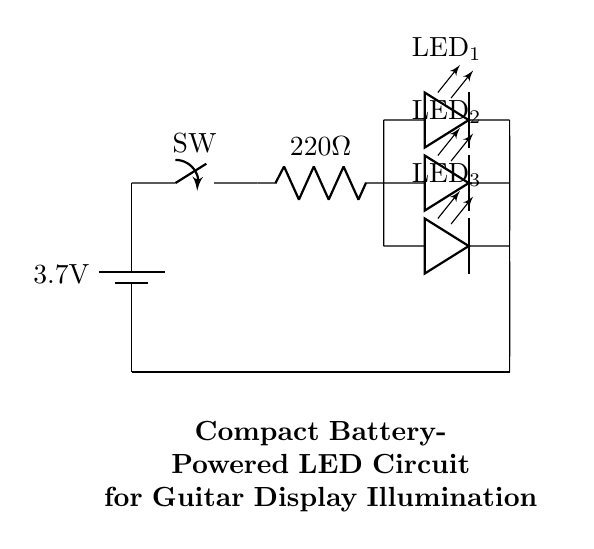What is the voltage of the battery? The circuit diagram shows a battery marked with a voltage of 3.7V. This is a direct indication of the voltage supply in the circuit.
Answer: 3.7 volts How many LEDs are there in this circuit? The circuit shows three LEDs connected in parallel. Counting the labeled LEDs in the diagram reveals that there are exactly three LEDs.
Answer: Three What is the resistance value of the resistor? In the diagram, there is a resistor labeled with a value of 220 ohms. This provides the resistance level for current limiting in the circuit.
Answer: 220 ohms What kind of switch is used in this circuit? The diagram indicates a switch labeled as "SW", which signifies a generic switch type commonly used for controlling circuits. While its specific type is not detailed, it is generally understood to be a toggle or slide switch.
Answer: Toggle switch Are the LEDs connected in series or parallel? Upon examining the connections in the diagram, the LED components branch off from a common point, indicating that they are in parallel. This means each LED receives the same voltage across them.
Answer: Parallel What is the purpose of the resistor in this circuit? The resistor is used to limit the current flowing through the LEDs. By converting the voltage from the battery and controlling the flow of current, it helps prevent the LEDs from burning out due to excessive current.
Answer: Current limiting What will happen if the switch is open? If the switch is open, there will be a break in the circuit, preventing current from flowing. This means that none of the LEDs will illuminate, as their circuit path will remain incomplete.
Answer: LEDs off 